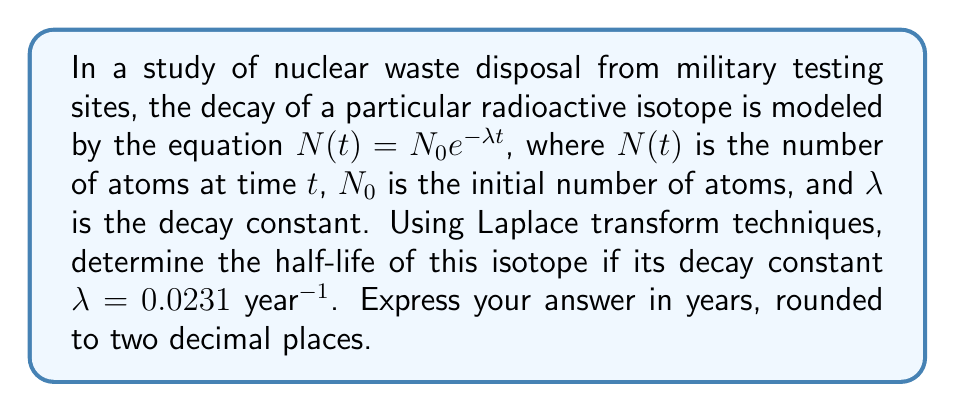Can you answer this question? Let's approach this step-by-step using Laplace transform techniques:

1) The half-life $t_{1/2}$ is the time it takes for half of the initial amount to decay. Mathematically, this means:

   $N(t_{1/2}) = \frac{1}{2}N_0$

2) Substituting this into our decay equation:

   $\frac{1}{2}N_0 = N_0e^{-\lambda t_{1/2}}$

3) Simplifying:

   $\frac{1}{2} = e^{-\lambda t_{1/2}}$

4) Taking the natural logarithm of both sides:

   $\ln(\frac{1}{2}) = -\lambda t_{1/2}$

5) Solving for $t_{1/2}$:

   $t_{1/2} = -\frac{\ln(\frac{1}{2})}{\lambda}$

6) Now, let's use the Laplace transform. The Laplace transform of $e^{-at}$ is $\frac{1}{s+a}$. In our case, $a = \lambda$.

7) Taking the Laplace transform of both sides of our original equation:

   $\mathcal{L}\{N(t)\} = \mathcal{L}\{N_0e^{-\lambda t}\}$

   $N(s) = N_0 \cdot \frac{1}{s+\lambda}$

8) The half-life corresponds to the pole of this transfer function, which occurs at $s = -\lambda$.

9) This confirms our earlier derivation. Substituting the given value $\lambda = 0.0231$ year$^{-1}$:

   $t_{1/2} = -\frac{\ln(\frac{1}{2})}{0.0231} \approx 30.0069$ years

10) Rounding to two decimal places gives us 30.01 years.
Answer: The half-life of the radioactive isotope is 30.01 years. 